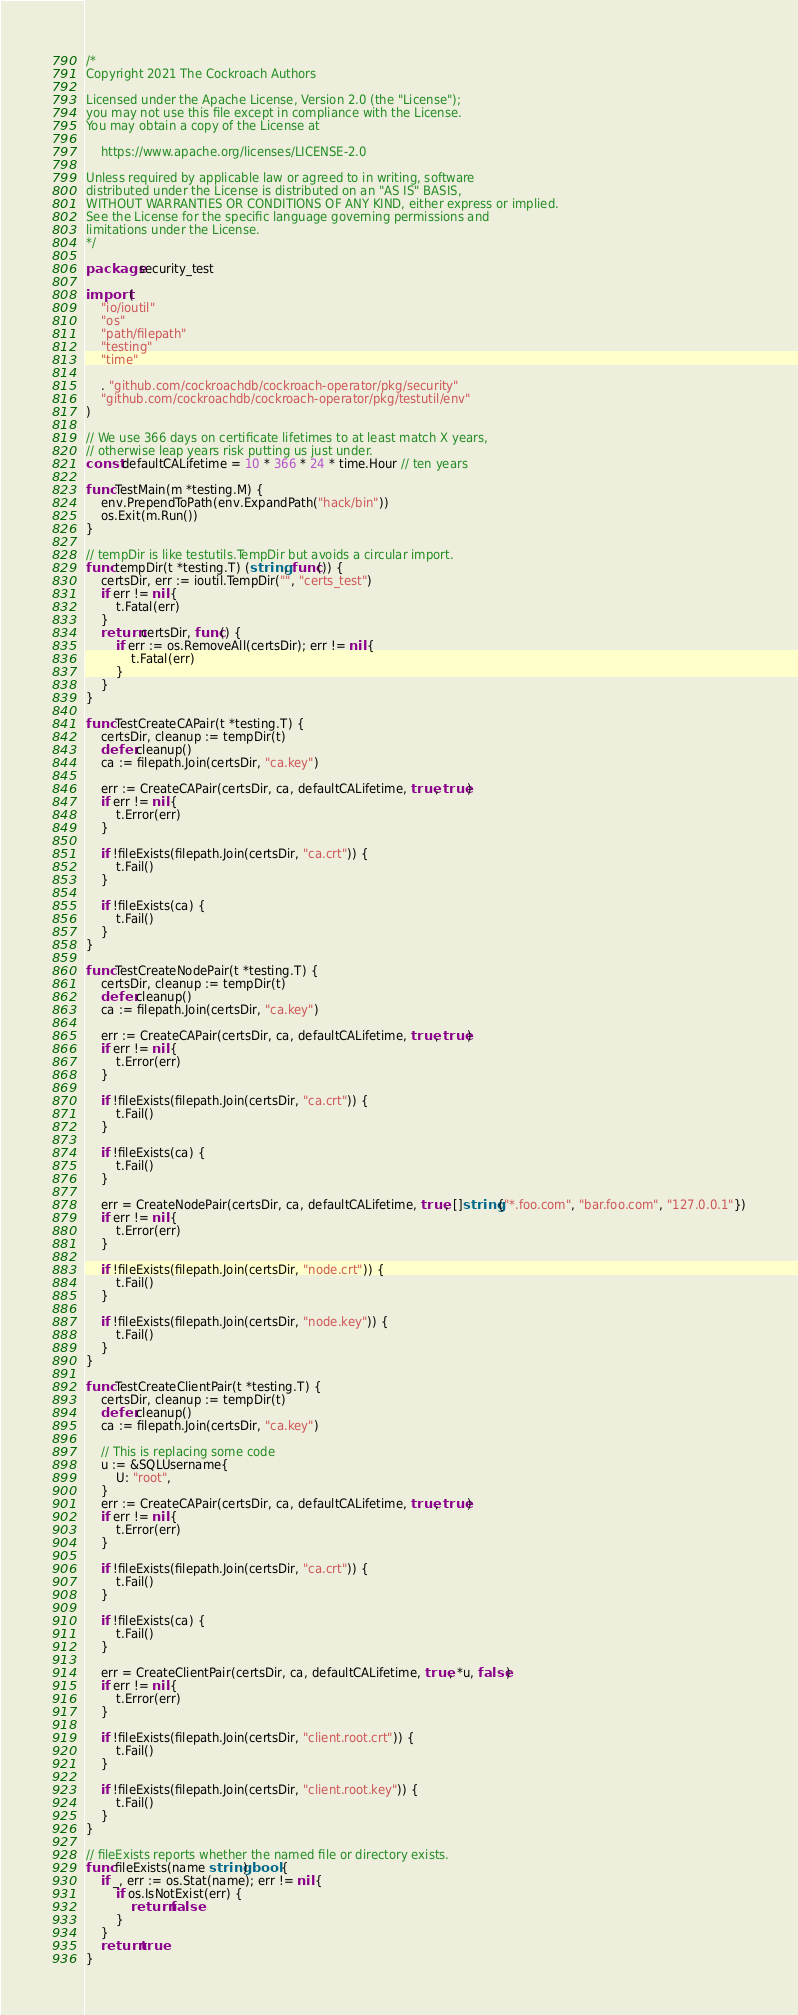Convert code to text. <code><loc_0><loc_0><loc_500><loc_500><_Go_>/*
Copyright 2021 The Cockroach Authors

Licensed under the Apache License, Version 2.0 (the "License");
you may not use this file except in compliance with the License.
You may obtain a copy of the License at

    https://www.apache.org/licenses/LICENSE-2.0

Unless required by applicable law or agreed to in writing, software
distributed under the License is distributed on an "AS IS" BASIS,
WITHOUT WARRANTIES OR CONDITIONS OF ANY KIND, either express or implied.
See the License for the specific language governing permissions and
limitations under the License.
*/

package security_test

import (
	"io/ioutil"
	"os"
	"path/filepath"
	"testing"
	"time"

	. "github.com/cockroachdb/cockroach-operator/pkg/security"
	"github.com/cockroachdb/cockroach-operator/pkg/testutil/env"
)

// We use 366 days on certificate lifetimes to at least match X years,
// otherwise leap years risk putting us just under.
const defaultCALifetime = 10 * 366 * 24 * time.Hour // ten years

func TestMain(m *testing.M) {
	env.PrependToPath(env.ExpandPath("hack/bin"))
	os.Exit(m.Run())
}

// tempDir is like testutils.TempDir but avoids a circular import.
func tempDir(t *testing.T) (string, func()) {
	certsDir, err := ioutil.TempDir("", "certs_test")
	if err != nil {
		t.Fatal(err)
	}
	return certsDir, func() {
		if err := os.RemoveAll(certsDir); err != nil {
			t.Fatal(err)
		}
	}
}

func TestCreateCAPair(t *testing.T) {
	certsDir, cleanup := tempDir(t)
	defer cleanup()
	ca := filepath.Join(certsDir, "ca.key")

	err := CreateCAPair(certsDir, ca, defaultCALifetime, true, true)
	if err != nil {
		t.Error(err)
	}

	if !fileExists(filepath.Join(certsDir, "ca.crt")) {
		t.Fail()
	}

	if !fileExists(ca) {
		t.Fail()
	}
}

func TestCreateNodePair(t *testing.T) {
	certsDir, cleanup := tempDir(t)
	defer cleanup()
	ca := filepath.Join(certsDir, "ca.key")

	err := CreateCAPair(certsDir, ca, defaultCALifetime, true, true)
	if err != nil {
		t.Error(err)
	}

	if !fileExists(filepath.Join(certsDir, "ca.crt")) {
		t.Fail()
	}

	if !fileExists(ca) {
		t.Fail()
	}

	err = CreateNodePair(certsDir, ca, defaultCALifetime, true, []string{"*.foo.com", "bar.foo.com", "127.0.0.1"})
	if err != nil {
		t.Error(err)
	}

	if !fileExists(filepath.Join(certsDir, "node.crt")) {
		t.Fail()
	}

	if !fileExists(filepath.Join(certsDir, "node.key")) {
		t.Fail()
	}
}

func TestCreateClientPair(t *testing.T) {
	certsDir, cleanup := tempDir(t)
	defer cleanup()
	ca := filepath.Join(certsDir, "ca.key")

	// This is replacing some code
	u := &SQLUsername{
		U: "root",
	}
	err := CreateCAPair(certsDir, ca, defaultCALifetime, true, true)
	if err != nil {
		t.Error(err)
	}

	if !fileExists(filepath.Join(certsDir, "ca.crt")) {
		t.Fail()
	}

	if !fileExists(ca) {
		t.Fail()
	}

	err = CreateClientPair(certsDir, ca, defaultCALifetime, true, *u, false)
	if err != nil {
		t.Error(err)
	}

	if !fileExists(filepath.Join(certsDir, "client.root.crt")) {
		t.Fail()
	}

	if !fileExists(filepath.Join(certsDir, "client.root.key")) {
		t.Fail()
	}
}

// fileExists reports whether the named file or directory exists.
func fileExists(name string) bool {
	if _, err := os.Stat(name); err != nil {
		if os.IsNotExist(err) {
			return false
		}
	}
	return true
}
</code> 